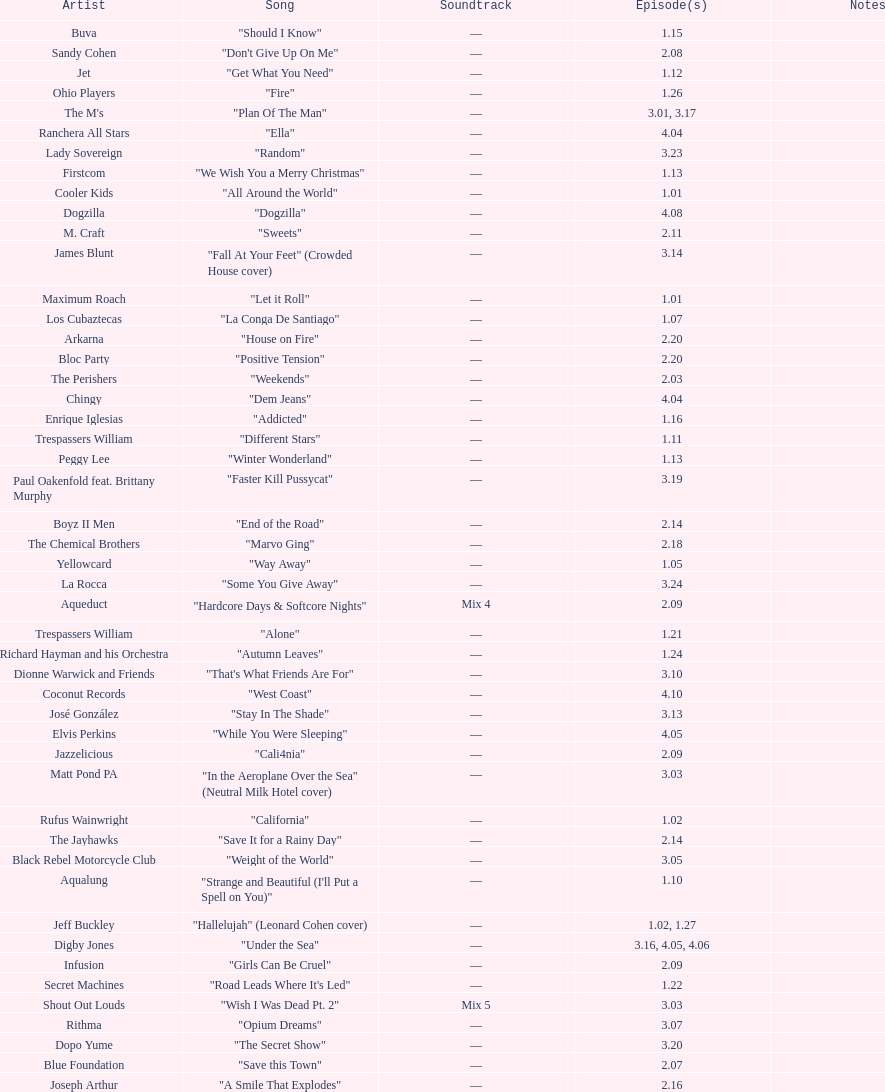How many episodes are below 2.00? 27. 